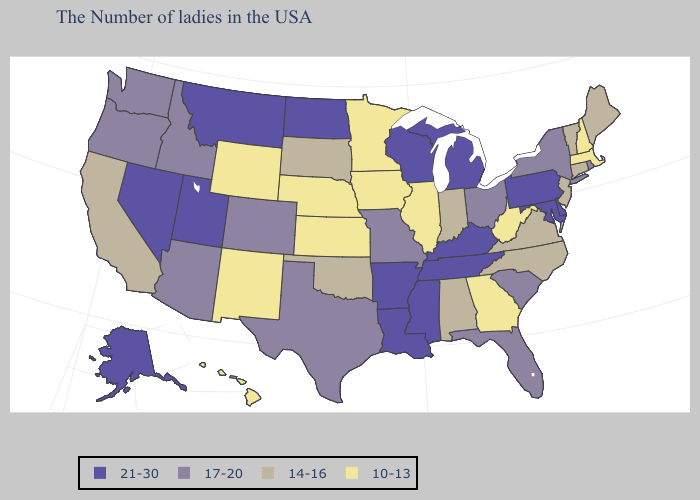What is the lowest value in the West?
Give a very brief answer. 10-13. Which states have the lowest value in the USA?
Give a very brief answer. Massachusetts, New Hampshire, West Virginia, Georgia, Illinois, Minnesota, Iowa, Kansas, Nebraska, Wyoming, New Mexico, Hawaii. What is the lowest value in the Northeast?
Write a very short answer. 10-13. What is the lowest value in the USA?
Keep it brief. 10-13. Name the states that have a value in the range 21-30?
Write a very short answer. Delaware, Maryland, Pennsylvania, Michigan, Kentucky, Tennessee, Wisconsin, Mississippi, Louisiana, Arkansas, North Dakota, Utah, Montana, Nevada, Alaska. Name the states that have a value in the range 21-30?
Short answer required. Delaware, Maryland, Pennsylvania, Michigan, Kentucky, Tennessee, Wisconsin, Mississippi, Louisiana, Arkansas, North Dakota, Utah, Montana, Nevada, Alaska. Which states hav the highest value in the South?
Give a very brief answer. Delaware, Maryland, Kentucky, Tennessee, Mississippi, Louisiana, Arkansas. Does Rhode Island have the same value as Virginia?
Concise answer only. No. What is the value of New Hampshire?
Write a very short answer. 10-13. Does Iowa have the lowest value in the MidWest?
Short answer required. Yes. Among the states that border Iowa , does South Dakota have the highest value?
Give a very brief answer. No. What is the value of Maryland?
Answer briefly. 21-30. Name the states that have a value in the range 17-20?
Write a very short answer. Rhode Island, New York, South Carolina, Ohio, Florida, Missouri, Texas, Colorado, Arizona, Idaho, Washington, Oregon. What is the value of Rhode Island?
Short answer required. 17-20. What is the value of Alaska?
Answer briefly. 21-30. 